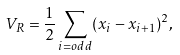<formula> <loc_0><loc_0><loc_500><loc_500>V _ { R } = \frac { 1 } { 2 } \sum _ { i = o d d } ( x _ { i } - x _ { i + 1 } ) ^ { 2 } ,</formula> 